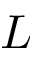<formula> <loc_0><loc_0><loc_500><loc_500>L</formula> 